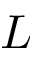<formula> <loc_0><loc_0><loc_500><loc_500>L</formula> 